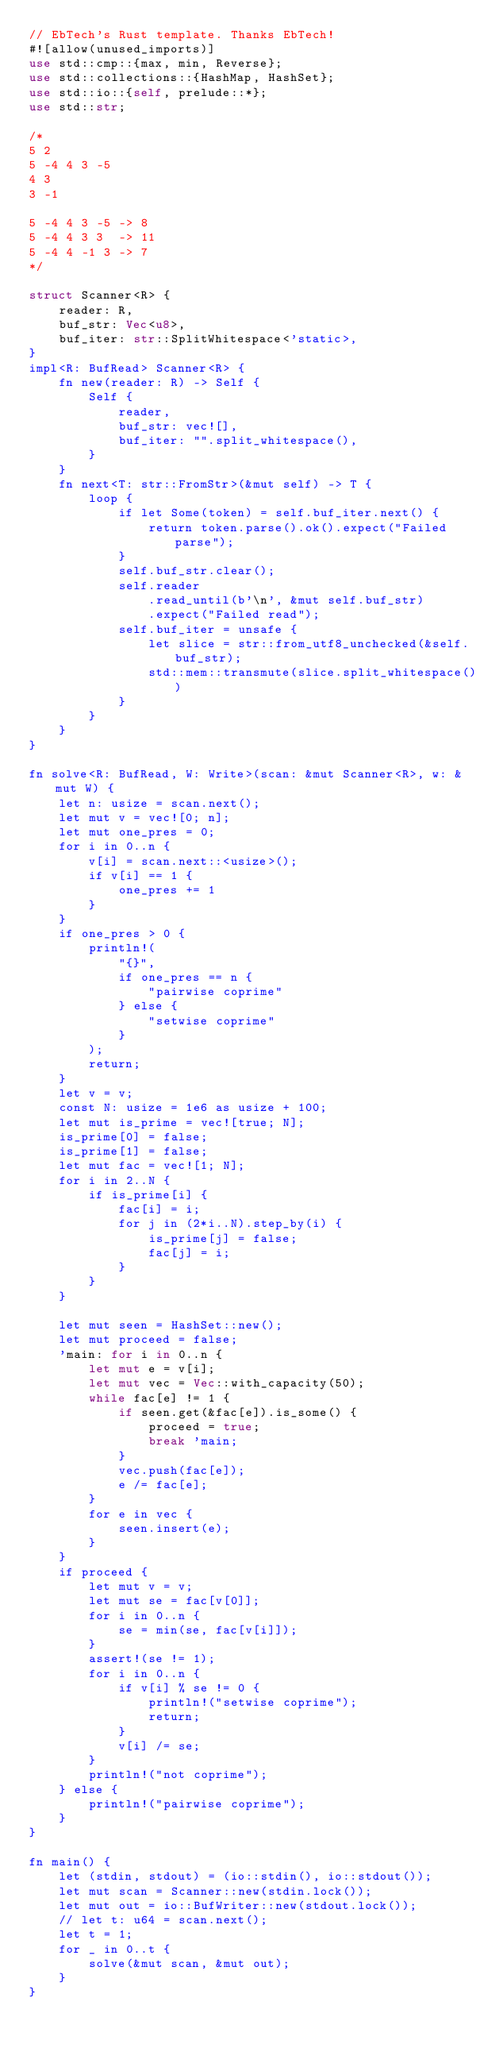<code> <loc_0><loc_0><loc_500><loc_500><_Rust_>// EbTech's Rust template. Thanks EbTech!
#![allow(unused_imports)]
use std::cmp::{max, min, Reverse};
use std::collections::{HashMap, HashSet};
use std::io::{self, prelude::*};
use std::str;

/*
5 2
5 -4 4 3 -5
4 3
3 -1

5 -4 4 3 -5 -> 8
5 -4 4 3 3  -> 11
5 -4 4 -1 3 -> 7
*/

struct Scanner<R> {
    reader: R,
    buf_str: Vec<u8>,
    buf_iter: str::SplitWhitespace<'static>,
}
impl<R: BufRead> Scanner<R> {
    fn new(reader: R) -> Self {
        Self {
            reader,
            buf_str: vec![],
            buf_iter: "".split_whitespace(),
        }
    }
    fn next<T: str::FromStr>(&mut self) -> T {
        loop {
            if let Some(token) = self.buf_iter.next() {
                return token.parse().ok().expect("Failed parse");
            }
            self.buf_str.clear();
            self.reader
                .read_until(b'\n', &mut self.buf_str)
                .expect("Failed read");
            self.buf_iter = unsafe {
                let slice = str::from_utf8_unchecked(&self.buf_str);
                std::mem::transmute(slice.split_whitespace())
            }
        }
    }
}

fn solve<R: BufRead, W: Write>(scan: &mut Scanner<R>, w: &mut W) {
    let n: usize = scan.next();
    let mut v = vec![0; n];
    let mut one_pres = 0;
    for i in 0..n {
        v[i] = scan.next::<usize>();
        if v[i] == 1 {
            one_pres += 1
        }
    }
    if one_pres > 0 {
        println!(
            "{}",
            if one_pres == n {
                "pairwise coprime"
            } else {
                "setwise coprime"
            }
        );
        return;
    }
    let v = v;
    const N: usize = 1e6 as usize + 100;
    let mut is_prime = vec![true; N];
    is_prime[0] = false;
    is_prime[1] = false;
    let mut fac = vec![1; N];
    for i in 2..N {
        if is_prime[i] {
            fac[i] = i;
            for j in (2*i..N).step_by(i) {
                is_prime[j] = false;
                fac[j] = i;
            }
        }
    }

    let mut seen = HashSet::new();
    let mut proceed = false;
    'main: for i in 0..n {
        let mut e = v[i];
        let mut vec = Vec::with_capacity(50);
        while fac[e] != 1 {
            if seen.get(&fac[e]).is_some() {
                proceed = true;
                break 'main;
            }
            vec.push(fac[e]);
            e /= fac[e];
        }
        for e in vec {
            seen.insert(e);
        }
    }
    if proceed {
        let mut v = v;
        let mut se = fac[v[0]];
        for i in 0..n {
            se = min(se, fac[v[i]]);
        }
        assert!(se != 1);
        for i in 0..n {
            if v[i] % se != 0 {
                println!("setwise coprime");
                return;
            }
            v[i] /= se;
        }
        println!("not coprime");
    } else {
        println!("pairwise coprime");
    }
}

fn main() {
    let (stdin, stdout) = (io::stdin(), io::stdout());
    let mut scan = Scanner::new(stdin.lock());
    let mut out = io::BufWriter::new(stdout.lock());
    // let t: u64 = scan.next();
    let t = 1;
    for _ in 0..t {
        solve(&mut scan, &mut out);
    }
}
</code> 